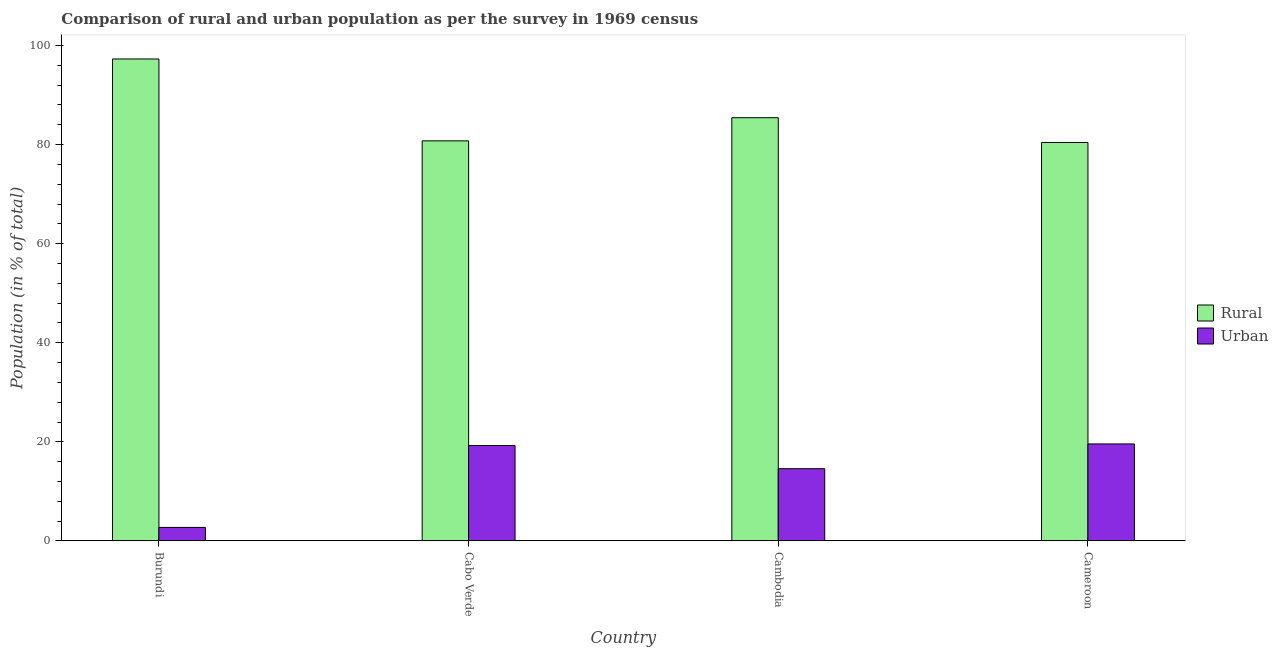How many different coloured bars are there?
Your answer should be compact. 2. How many groups of bars are there?
Offer a very short reply. 4. Are the number of bars on each tick of the X-axis equal?
Offer a terse response. Yes. What is the label of the 2nd group of bars from the left?
Provide a short and direct response. Cabo Verde. In how many cases, is the number of bars for a given country not equal to the number of legend labels?
Provide a short and direct response. 0. What is the rural population in Cabo Verde?
Keep it short and to the point. 80.75. Across all countries, what is the maximum urban population?
Provide a succinct answer. 19.58. Across all countries, what is the minimum rural population?
Your response must be concise. 80.42. In which country was the urban population maximum?
Provide a short and direct response. Cameroon. In which country was the urban population minimum?
Provide a succinct answer. Burundi. What is the total rural population in the graph?
Your answer should be very brief. 343.86. What is the difference between the urban population in Burundi and that in Cambodia?
Give a very brief answer. -11.85. What is the difference between the rural population in Cambodia and the urban population in Cameroon?
Your answer should be compact. 65.84. What is the average urban population per country?
Give a very brief answer. 14.03. What is the difference between the urban population and rural population in Cambodia?
Give a very brief answer. -70.84. In how many countries, is the urban population greater than 72 %?
Offer a very short reply. 0. What is the ratio of the urban population in Cambodia to that in Cameroon?
Offer a terse response. 0.74. Is the urban population in Cabo Verde less than that in Cambodia?
Make the answer very short. No. Is the difference between the urban population in Cabo Verde and Cameroon greater than the difference between the rural population in Cabo Verde and Cameroon?
Provide a short and direct response. No. What is the difference between the highest and the second highest rural population?
Your answer should be compact. 11.85. What is the difference between the highest and the lowest rural population?
Offer a very short reply. 16.85. In how many countries, is the rural population greater than the average rural population taken over all countries?
Make the answer very short. 1. What does the 2nd bar from the left in Cameroon represents?
Offer a terse response. Urban. What does the 2nd bar from the right in Burundi represents?
Keep it short and to the point. Rural. Are all the bars in the graph horizontal?
Keep it short and to the point. No. How many countries are there in the graph?
Keep it short and to the point. 4. Are the values on the major ticks of Y-axis written in scientific E-notation?
Give a very brief answer. No. Where does the legend appear in the graph?
Make the answer very short. Center right. How are the legend labels stacked?
Provide a succinct answer. Vertical. What is the title of the graph?
Keep it short and to the point. Comparison of rural and urban population as per the survey in 1969 census. Does "Girls" appear as one of the legend labels in the graph?
Your response must be concise. No. What is the label or title of the Y-axis?
Make the answer very short. Population (in % of total). What is the Population (in % of total) of Rural in Burundi?
Your answer should be compact. 97.27. What is the Population (in % of total) of Urban in Burundi?
Provide a short and direct response. 2.73. What is the Population (in % of total) of Rural in Cabo Verde?
Offer a terse response. 80.75. What is the Population (in % of total) in Urban in Cabo Verde?
Your answer should be compact. 19.25. What is the Population (in % of total) in Rural in Cambodia?
Provide a succinct answer. 85.42. What is the Population (in % of total) of Urban in Cambodia?
Keep it short and to the point. 14.58. What is the Population (in % of total) of Rural in Cameroon?
Give a very brief answer. 80.42. What is the Population (in % of total) in Urban in Cameroon?
Offer a very short reply. 19.58. Across all countries, what is the maximum Population (in % of total) in Rural?
Provide a short and direct response. 97.27. Across all countries, what is the maximum Population (in % of total) in Urban?
Your answer should be very brief. 19.58. Across all countries, what is the minimum Population (in % of total) in Rural?
Make the answer very short. 80.42. Across all countries, what is the minimum Population (in % of total) of Urban?
Provide a succinct answer. 2.73. What is the total Population (in % of total) in Rural in the graph?
Provide a succinct answer. 343.86. What is the total Population (in % of total) in Urban in the graph?
Keep it short and to the point. 56.14. What is the difference between the Population (in % of total) in Rural in Burundi and that in Cabo Verde?
Ensure brevity in your answer.  16.53. What is the difference between the Population (in % of total) of Urban in Burundi and that in Cabo Verde?
Provide a short and direct response. -16.53. What is the difference between the Population (in % of total) of Rural in Burundi and that in Cambodia?
Keep it short and to the point. 11.85. What is the difference between the Population (in % of total) in Urban in Burundi and that in Cambodia?
Offer a terse response. -11.85. What is the difference between the Population (in % of total) in Rural in Burundi and that in Cameroon?
Provide a succinct answer. 16.85. What is the difference between the Population (in % of total) in Urban in Burundi and that in Cameroon?
Ensure brevity in your answer.  -16.85. What is the difference between the Population (in % of total) of Rural in Cabo Verde and that in Cambodia?
Ensure brevity in your answer.  -4.68. What is the difference between the Population (in % of total) of Urban in Cabo Verde and that in Cambodia?
Provide a short and direct response. 4.68. What is the difference between the Population (in % of total) in Rural in Cabo Verde and that in Cameroon?
Ensure brevity in your answer.  0.32. What is the difference between the Population (in % of total) in Urban in Cabo Verde and that in Cameroon?
Your response must be concise. -0.32. What is the difference between the Population (in % of total) in Rural in Cambodia and that in Cameroon?
Your answer should be very brief. 5. What is the difference between the Population (in % of total) in Urban in Cambodia and that in Cameroon?
Keep it short and to the point. -5. What is the difference between the Population (in % of total) in Rural in Burundi and the Population (in % of total) in Urban in Cabo Verde?
Provide a succinct answer. 78.02. What is the difference between the Population (in % of total) of Rural in Burundi and the Population (in % of total) of Urban in Cambodia?
Offer a very short reply. 82.69. What is the difference between the Population (in % of total) of Rural in Burundi and the Population (in % of total) of Urban in Cameroon?
Your response must be concise. 77.7. What is the difference between the Population (in % of total) of Rural in Cabo Verde and the Population (in % of total) of Urban in Cambodia?
Keep it short and to the point. 66.17. What is the difference between the Population (in % of total) in Rural in Cabo Verde and the Population (in % of total) in Urban in Cameroon?
Provide a succinct answer. 61.17. What is the difference between the Population (in % of total) in Rural in Cambodia and the Population (in % of total) in Urban in Cameroon?
Offer a very short reply. 65.84. What is the average Population (in % of total) of Rural per country?
Offer a terse response. 85.97. What is the average Population (in % of total) of Urban per country?
Give a very brief answer. 14.03. What is the difference between the Population (in % of total) in Rural and Population (in % of total) in Urban in Burundi?
Offer a very short reply. 94.55. What is the difference between the Population (in % of total) of Rural and Population (in % of total) of Urban in Cabo Verde?
Keep it short and to the point. 61.49. What is the difference between the Population (in % of total) of Rural and Population (in % of total) of Urban in Cambodia?
Ensure brevity in your answer.  70.84. What is the difference between the Population (in % of total) in Rural and Population (in % of total) in Urban in Cameroon?
Give a very brief answer. 60.85. What is the ratio of the Population (in % of total) in Rural in Burundi to that in Cabo Verde?
Offer a very short reply. 1.2. What is the ratio of the Population (in % of total) in Urban in Burundi to that in Cabo Verde?
Your answer should be very brief. 0.14. What is the ratio of the Population (in % of total) in Rural in Burundi to that in Cambodia?
Make the answer very short. 1.14. What is the ratio of the Population (in % of total) in Urban in Burundi to that in Cambodia?
Give a very brief answer. 0.19. What is the ratio of the Population (in % of total) of Rural in Burundi to that in Cameroon?
Offer a very short reply. 1.21. What is the ratio of the Population (in % of total) in Urban in Burundi to that in Cameroon?
Ensure brevity in your answer.  0.14. What is the ratio of the Population (in % of total) of Rural in Cabo Verde to that in Cambodia?
Offer a terse response. 0.95. What is the ratio of the Population (in % of total) of Urban in Cabo Verde to that in Cambodia?
Your response must be concise. 1.32. What is the ratio of the Population (in % of total) of Urban in Cabo Verde to that in Cameroon?
Your response must be concise. 0.98. What is the ratio of the Population (in % of total) in Rural in Cambodia to that in Cameroon?
Offer a very short reply. 1.06. What is the ratio of the Population (in % of total) of Urban in Cambodia to that in Cameroon?
Your response must be concise. 0.74. What is the difference between the highest and the second highest Population (in % of total) in Rural?
Give a very brief answer. 11.85. What is the difference between the highest and the second highest Population (in % of total) of Urban?
Your response must be concise. 0.32. What is the difference between the highest and the lowest Population (in % of total) in Rural?
Your answer should be compact. 16.85. What is the difference between the highest and the lowest Population (in % of total) in Urban?
Keep it short and to the point. 16.85. 